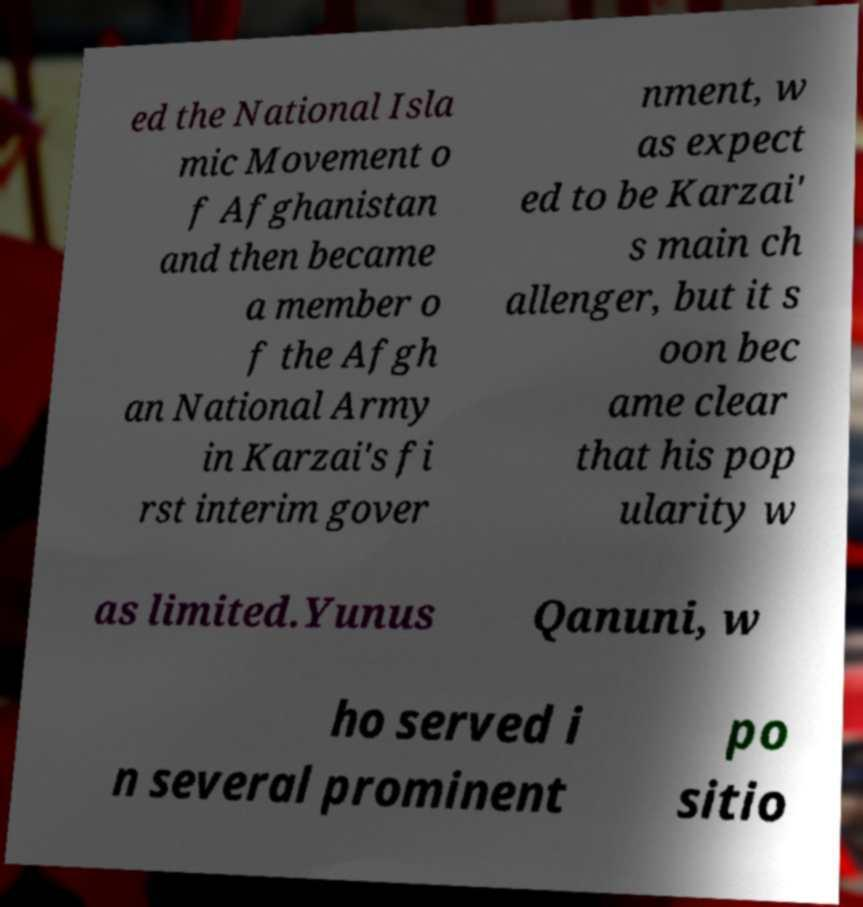Please read and relay the text visible in this image. What does it say? ed the National Isla mic Movement o f Afghanistan and then became a member o f the Afgh an National Army in Karzai's fi rst interim gover nment, w as expect ed to be Karzai' s main ch allenger, but it s oon bec ame clear that his pop ularity w as limited.Yunus Qanuni, w ho served i n several prominent po sitio 